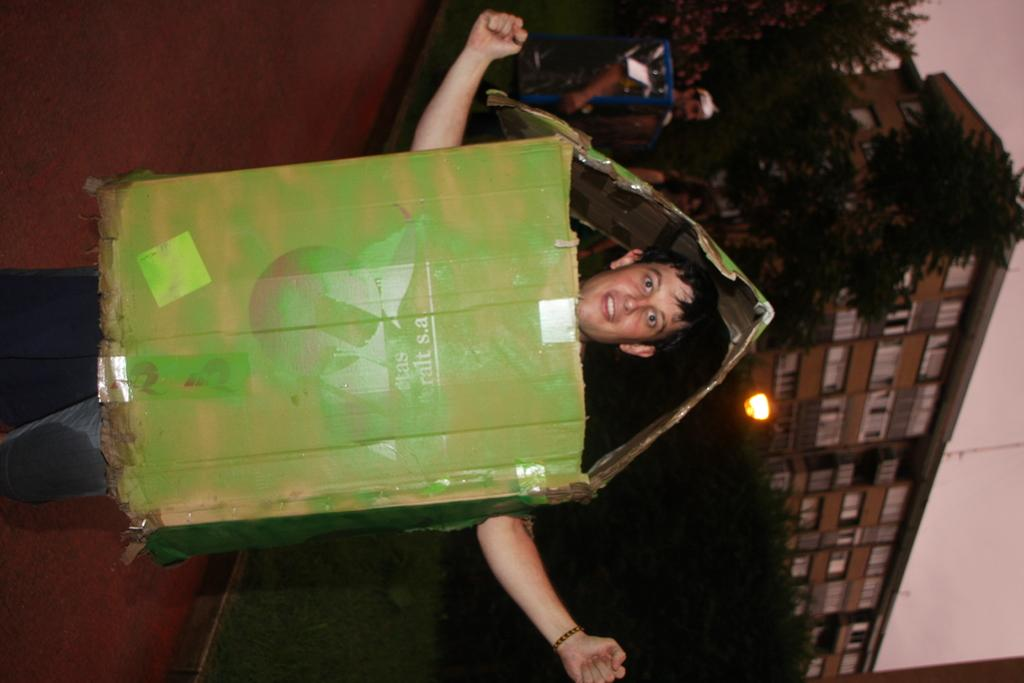How is the image oriented? A: The image is tilted. What can be seen in the foreground of the image? There is a man standing in the image. What is the man wearing in the image? The man is wearing a box. Where is the man standing in the image? The man is standing on a road. What is visible in the background of the image? There are trees, lights, and buildings in the background of the image. What type of truck can be seen driving past the man in the image? There is no truck present in the image; it only features a man standing on a road with a box on. --- Facts: 1. There is a person sitting on a chair in the image. 2. The person is holding a book. 3. The book has a blue cover. 4. The chair is made of wood. 5. There is a table next to the chair. 6. The table has a lamp on it. Absurd Topics: elephant, ocean, bicycle Conversation: What is the person in the image doing? The person is sitting on a chair in the image. What is the person holding in the image? The person is holding a book in the image. What color is the book's cover? The book has a blue cover. What is the chair made of? The chair is made of wood. What is located next to the chair in the image? There is a table next to the chair in the image. What is on the table in the image? The table has a lamp on it. Reasoning: Let's think step by step in order to produce the conversation. We start by identifying the main subject in the image, which is the person sitting on a chair. Then, we expand the conversation to include the book the person is holding, noting its color. Next, we describe the chair and the table next to it. Finally, we mention the lamp on the table. Each question is designed to elicit a specific detail about the image that is known from the provided facts. Absurd Question/Answer: Can you see an elephant swimming in the ocean in the image? There is no elephant or ocean present in the image; it only features a person sitting on a chair holding a book. 